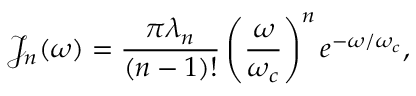<formula> <loc_0><loc_0><loc_500><loc_500>{ \mathcal { J } } _ { n } ( \omega ) = \frac { \pi \lambda _ { n } } { ( n - 1 ) ! } \left ( \frac { \omega } { \omega _ { c } } \right ) ^ { n } e ^ { - \omega / \omega _ { c } } ,</formula> 